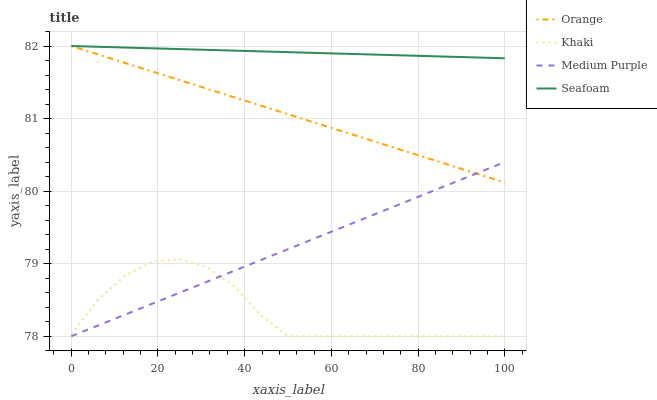Does Khaki have the minimum area under the curve?
Answer yes or no. Yes. Does Seafoam have the maximum area under the curve?
Answer yes or no. Yes. Does Medium Purple have the minimum area under the curve?
Answer yes or no. No. Does Medium Purple have the maximum area under the curve?
Answer yes or no. No. Is Medium Purple the smoothest?
Answer yes or no. Yes. Is Khaki the roughest?
Answer yes or no. Yes. Is Khaki the smoothest?
Answer yes or no. No. Is Medium Purple the roughest?
Answer yes or no. No. Does Medium Purple have the lowest value?
Answer yes or no. Yes. Does Seafoam have the lowest value?
Answer yes or no. No. Does Seafoam have the highest value?
Answer yes or no. Yes. Does Medium Purple have the highest value?
Answer yes or no. No. Is Khaki less than Orange?
Answer yes or no. Yes. Is Seafoam greater than Medium Purple?
Answer yes or no. Yes. Does Seafoam intersect Orange?
Answer yes or no. Yes. Is Seafoam less than Orange?
Answer yes or no. No. Is Seafoam greater than Orange?
Answer yes or no. No. Does Khaki intersect Orange?
Answer yes or no. No. 